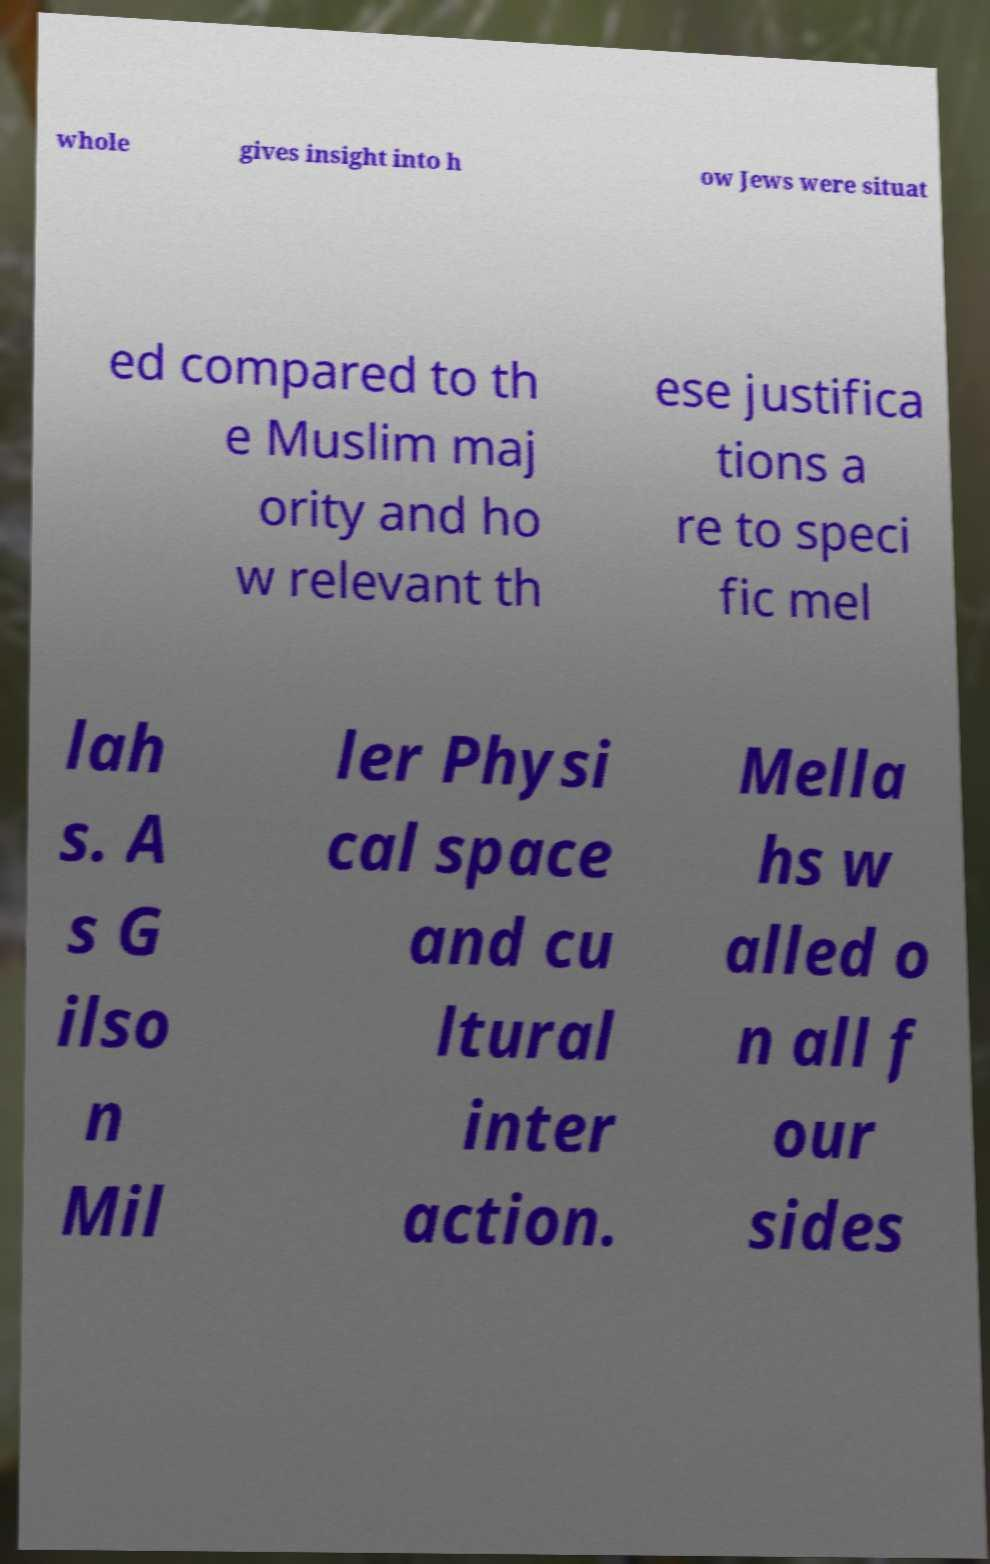Can you read and provide the text displayed in the image?This photo seems to have some interesting text. Can you extract and type it out for me? whole gives insight into h ow Jews were situat ed compared to th e Muslim maj ority and ho w relevant th ese justifica tions a re to speci fic mel lah s. A s G ilso n Mil ler Physi cal space and cu ltural inter action. Mella hs w alled o n all f our sides 